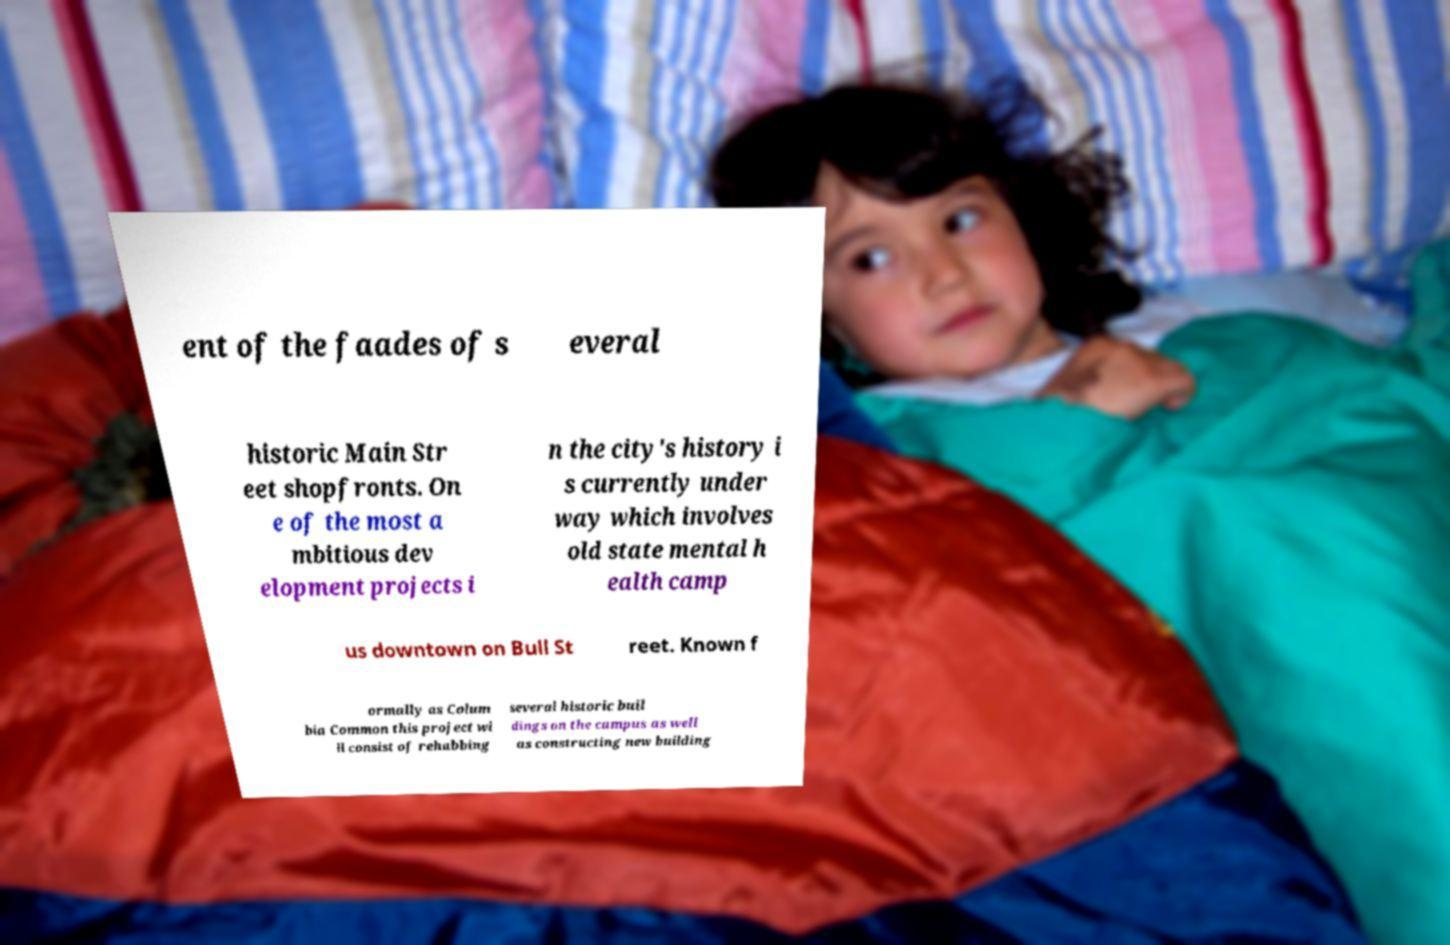Can you read and provide the text displayed in the image?This photo seems to have some interesting text. Can you extract and type it out for me? ent of the faades of s everal historic Main Str eet shopfronts. On e of the most a mbitious dev elopment projects i n the city's history i s currently under way which involves old state mental h ealth camp us downtown on Bull St reet. Known f ormally as Colum bia Common this project wi ll consist of rehabbing several historic buil dings on the campus as well as constructing new building 